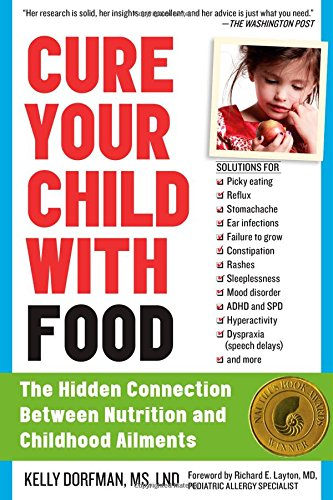Is this book related to Health, Fitness & Dieting? Yes, it directly relates to Health, Fitness & Dieting, offering insights into how nutrition influences various childhood ailments, a critical resource for parents and caregivers. 